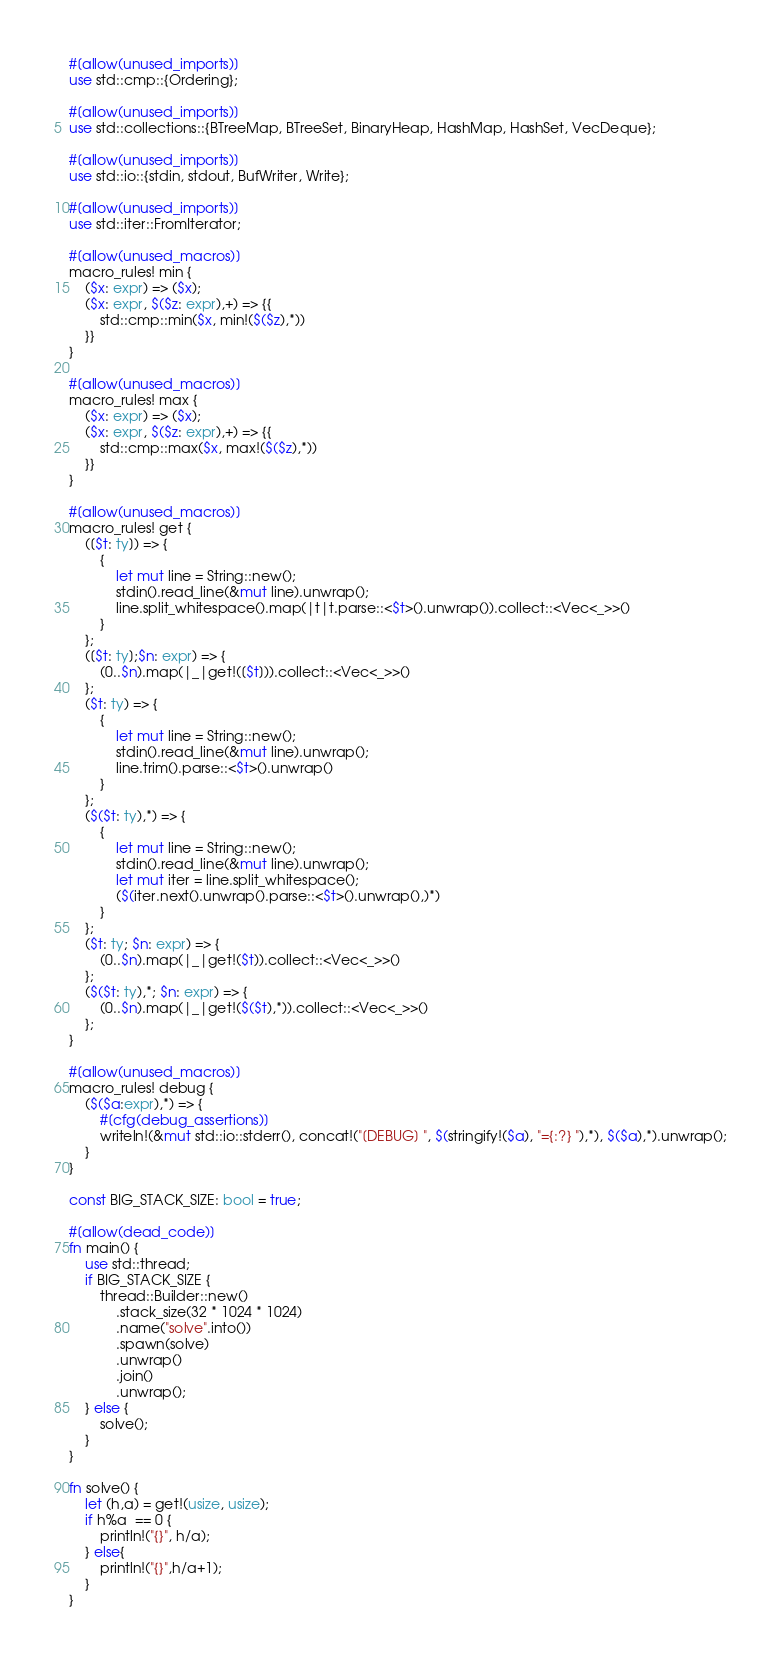<code> <loc_0><loc_0><loc_500><loc_500><_Rust_>#[allow(unused_imports)]
use std::cmp::{Ordering};

#[allow(unused_imports)]
use std::collections::{BTreeMap, BTreeSet, BinaryHeap, HashMap, HashSet, VecDeque};

#[allow(unused_imports)]
use std::io::{stdin, stdout, BufWriter, Write};

#[allow(unused_imports)]
use std::iter::FromIterator;

#[allow(unused_macros)]
macro_rules! min {
    ($x: expr) => ($x);
    ($x: expr, $($z: expr),+) => {{
        std::cmp::min($x, min!($($z),*))
    }}
}

#[allow(unused_macros)]
macro_rules! max {
    ($x: expr) => ($x);
    ($x: expr, $($z: expr),+) => {{
        std::cmp::max($x, max!($($z),*))
    }}
}

#[allow(unused_macros)]
macro_rules! get { 
    ([$t: ty]) => { 
        { 
            let mut line = String::new(); 
            stdin().read_line(&mut line).unwrap(); 
            line.split_whitespace().map(|t|t.parse::<$t>().unwrap()).collect::<Vec<_>>()
        }
    };
    ([$t: ty];$n: expr) => {
        (0..$n).map(|_|get!([$t])).collect::<Vec<_>>()
    };
    ($t: ty) => {
        {
            let mut line = String::new();
            stdin().read_line(&mut line).unwrap();
            line.trim().parse::<$t>().unwrap()
        }
    };
    ($($t: ty),*) => {
        { 
            let mut line = String::new();
            stdin().read_line(&mut line).unwrap();
            let mut iter = line.split_whitespace();
            ($(iter.next().unwrap().parse::<$t>().unwrap(),)*)
        }
    };
    ($t: ty; $n: expr) => {
        (0..$n).map(|_|get!($t)).collect::<Vec<_>>()
    };
    ($($t: ty),*; $n: expr) => {
        (0..$n).map(|_|get!($($t),*)).collect::<Vec<_>>()
    };
}

#[allow(unused_macros)]
macro_rules! debug {
    ($($a:expr),*) => {
        #[cfg(debug_assertions)]
        writeln!(&mut std::io::stderr(), concat!("[DEBUG] ", $(stringify!($a), "={:?} "),*), $($a),*).unwrap();
    }
}

const BIG_STACK_SIZE: bool = true;

#[allow(dead_code)]
fn main() {
    use std::thread;
    if BIG_STACK_SIZE {
        thread::Builder::new()
            .stack_size(32 * 1024 * 1024)
            .name("solve".into())
            .spawn(solve)
            .unwrap()
            .join()
            .unwrap();
    } else {
        solve();
    }
}

fn solve() {
    let (h,a) = get!(usize, usize);
    if h%a  == 0 {
        println!("{}", h/a);
    } else{
        println!("{}",h/a+1);
    }
}
</code> 